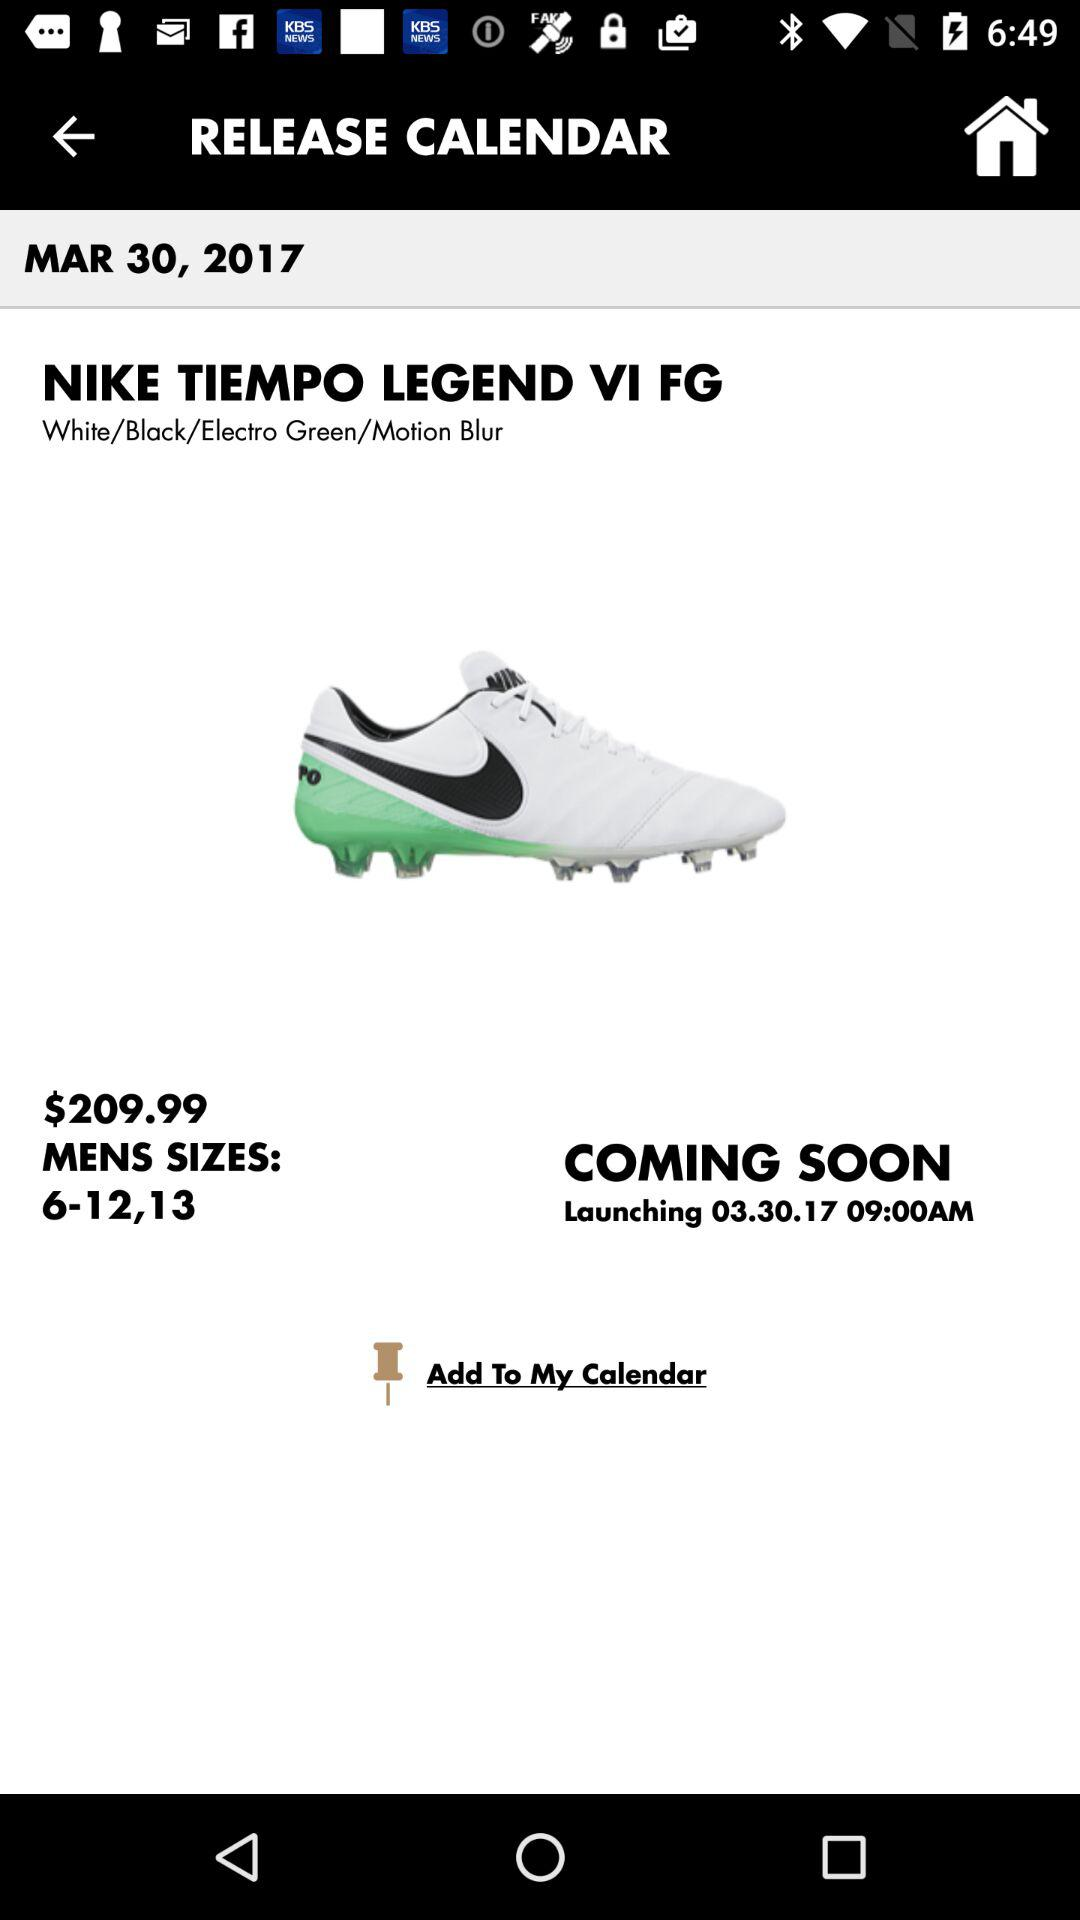How much is the shoe?
Answer the question using a single word or phrase. $209.99 